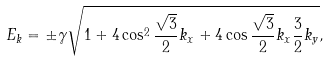Convert formula to latex. <formula><loc_0><loc_0><loc_500><loc_500>E _ { k } = \pm \gamma \sqrt { 1 + 4 \cos ^ { 2 } \frac { \sqrt { 3 } } { 2 } k _ { x } + 4 \cos \frac { \sqrt { 3 } } { 2 } k _ { x } \frac { 3 } { 2 } k _ { y } } ,</formula> 